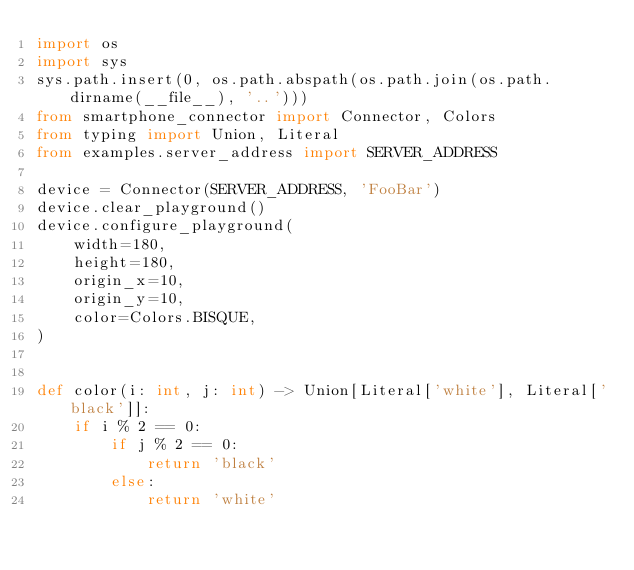<code> <loc_0><loc_0><loc_500><loc_500><_Python_>import os
import sys
sys.path.insert(0, os.path.abspath(os.path.join(os.path.dirname(__file__), '..')))
from smartphone_connector import Connector, Colors
from typing import Union, Literal
from examples.server_address import SERVER_ADDRESS

device = Connector(SERVER_ADDRESS, 'FooBar')
device.clear_playground()
device.configure_playground(
    width=180,
    height=180,
    origin_x=10,
    origin_y=10,
    color=Colors.BISQUE,
)


def color(i: int, j: int) -> Union[Literal['white'], Literal['black']]:
    if i % 2 == 0:
        if j % 2 == 0:
            return 'black'
        else:
            return 'white'</code> 